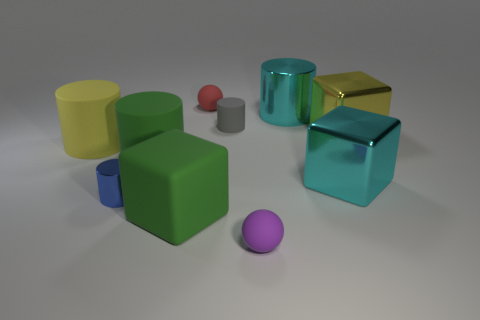There is a metallic cylinder that is right of the small cylinder that is left of the tiny sphere behind the blue metallic thing; what size is it?
Your answer should be compact. Large. There is a small blue object; what shape is it?
Offer a very short reply. Cylinder. There is a matte ball that is in front of the tiny red rubber object; how many big cubes are left of it?
Offer a very short reply. 1. How many other objects are there of the same material as the tiny purple thing?
Provide a succinct answer. 5. Are the big yellow object left of the large cyan cylinder and the small ball behind the large green matte cube made of the same material?
Keep it short and to the point. Yes. Is there anything else that has the same shape as the yellow shiny thing?
Provide a short and direct response. Yes. Do the small gray thing and the tiny cylinder in front of the big yellow rubber thing have the same material?
Your answer should be very brief. No. The metal thing that is on the left side of the cyan cylinder that is to the right of the small gray matte object that is behind the small metallic object is what color?
Offer a very short reply. Blue. The yellow matte thing that is the same size as the yellow block is what shape?
Give a very brief answer. Cylinder. Are there any other things that are the same size as the red object?
Your answer should be very brief. Yes. 